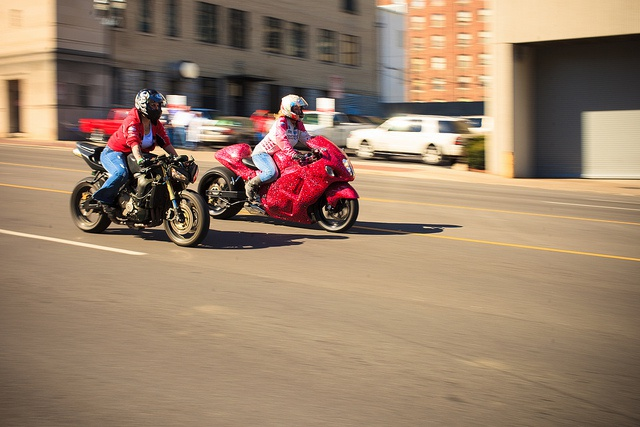Describe the objects in this image and their specific colors. I can see motorcycle in tan, black, red, maroon, and brown tones, motorcycle in tan, black, and gray tones, car in tan, ivory, olive, and gray tones, people in tan, black, maroon, salmon, and lightblue tones, and people in tan, white, black, gray, and lightpink tones in this image. 